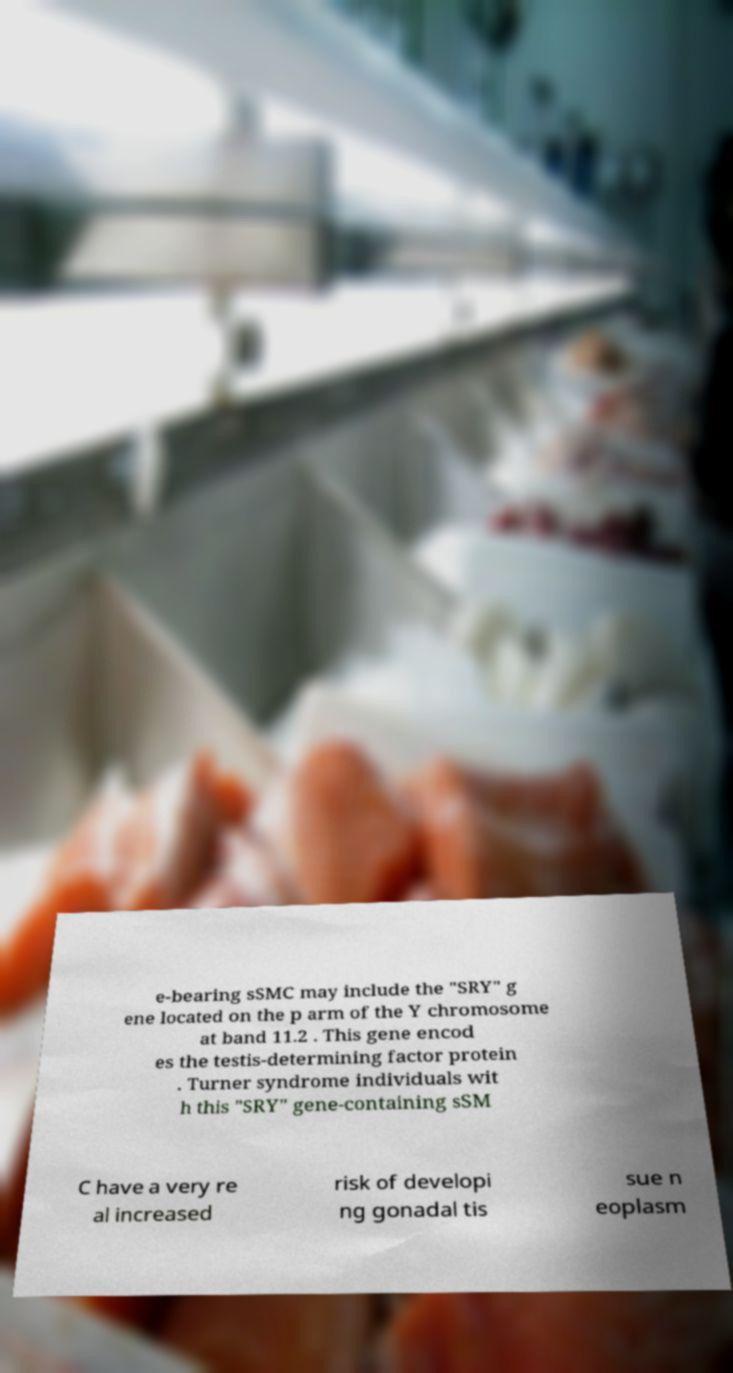Could you extract and type out the text from this image? e-bearing sSMC may include the "SRY" g ene located on the p arm of the Y chromosome at band 11.2 . This gene encod es the testis-determining factor protein . Turner syndrome individuals wit h this "SRY" gene-containing sSM C have a very re al increased risk of developi ng gonadal tis sue n eoplasm 